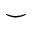Convert formula to latex. <formula><loc_0><loc_0><loc_500><loc_500>\smile</formula> 